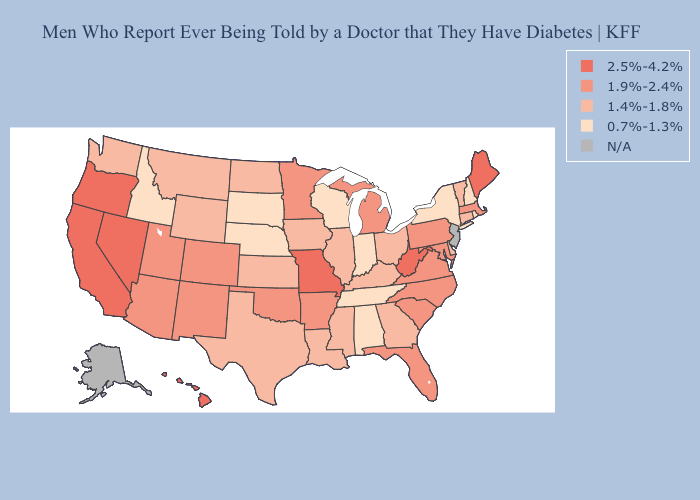What is the highest value in states that border California?
Concise answer only. 2.5%-4.2%. Name the states that have a value in the range 1.4%-1.8%?
Give a very brief answer. Connecticut, Delaware, Georgia, Illinois, Iowa, Kansas, Kentucky, Louisiana, Mississippi, Montana, North Dakota, Ohio, Texas, Vermont, Washington, Wyoming. Does the first symbol in the legend represent the smallest category?
Answer briefly. No. Name the states that have a value in the range 1.9%-2.4%?
Be succinct. Arizona, Arkansas, Colorado, Florida, Maryland, Massachusetts, Michigan, Minnesota, New Mexico, North Carolina, Oklahoma, Pennsylvania, South Carolina, Utah, Virginia. Name the states that have a value in the range 2.5%-4.2%?
Keep it brief. California, Hawaii, Maine, Missouri, Nevada, Oregon, West Virginia. Name the states that have a value in the range 1.4%-1.8%?
Answer briefly. Connecticut, Delaware, Georgia, Illinois, Iowa, Kansas, Kentucky, Louisiana, Mississippi, Montana, North Dakota, Ohio, Texas, Vermont, Washington, Wyoming. Among the states that border Ohio , which have the lowest value?
Answer briefly. Indiana. Does Michigan have the highest value in the MidWest?
Keep it brief. No. Which states have the lowest value in the West?
Give a very brief answer. Idaho. Name the states that have a value in the range 1.9%-2.4%?
Answer briefly. Arizona, Arkansas, Colorado, Florida, Maryland, Massachusetts, Michigan, Minnesota, New Mexico, North Carolina, Oklahoma, Pennsylvania, South Carolina, Utah, Virginia. What is the value of Massachusetts?
Short answer required. 1.9%-2.4%. Does North Dakota have the lowest value in the MidWest?
Write a very short answer. No. Does Indiana have the highest value in the MidWest?
Quick response, please. No. 